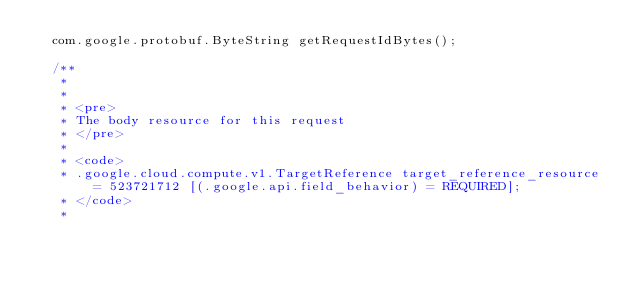<code> <loc_0><loc_0><loc_500><loc_500><_Java_>  com.google.protobuf.ByteString getRequestIdBytes();

  /**
   *
   *
   * <pre>
   * The body resource for this request
   * </pre>
   *
   * <code>
   * .google.cloud.compute.v1.TargetReference target_reference_resource = 523721712 [(.google.api.field_behavior) = REQUIRED];
   * </code>
   *</code> 